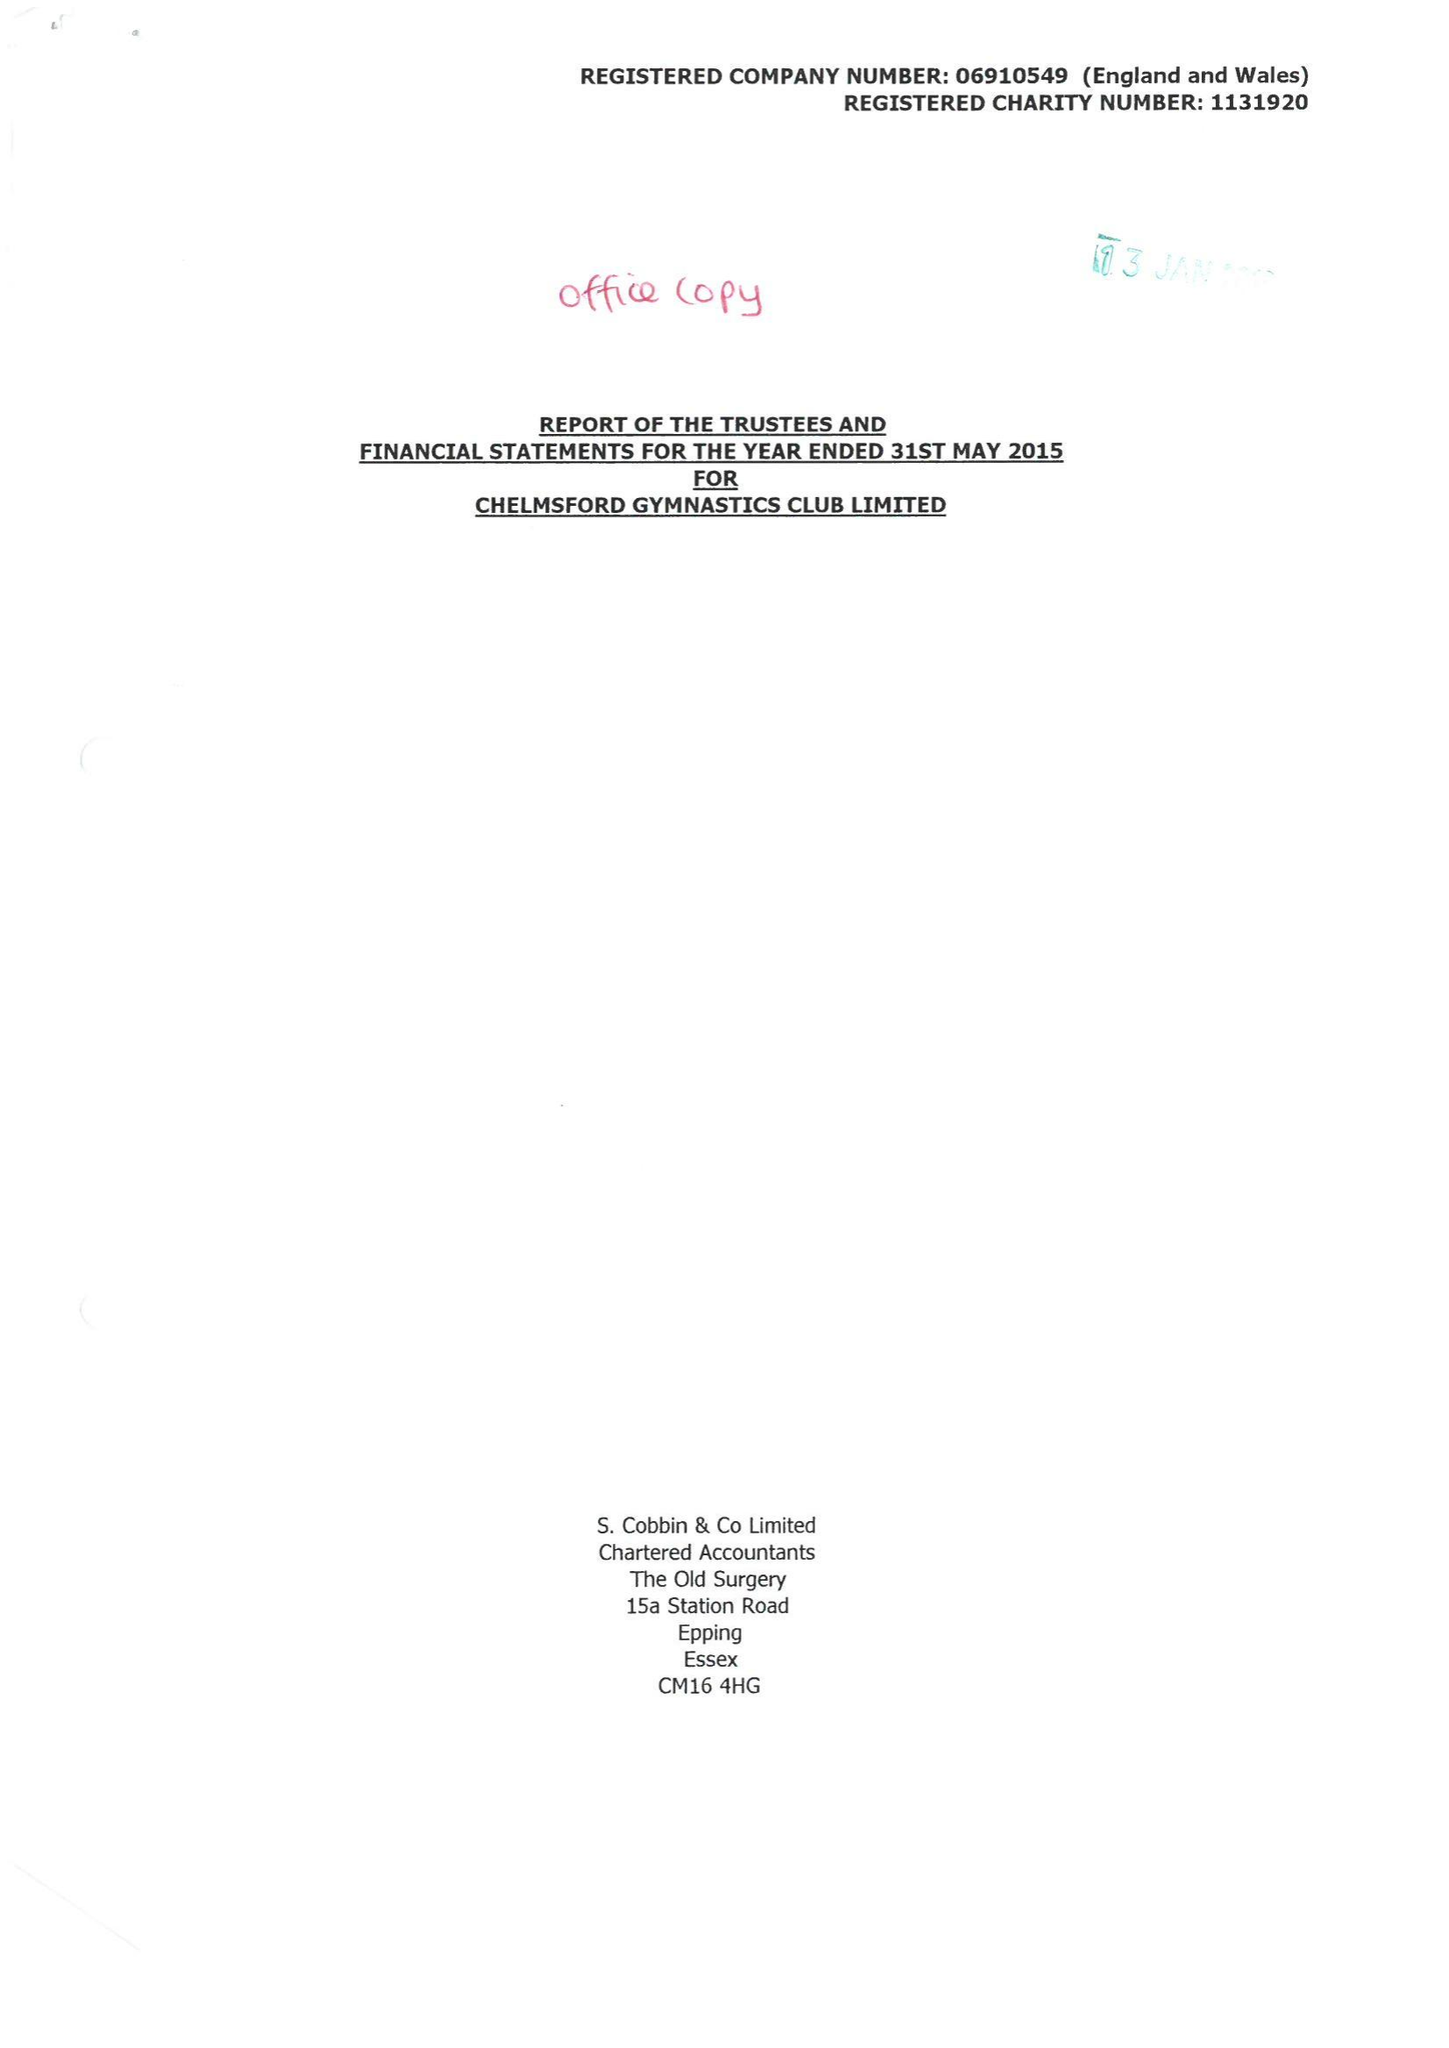What is the value for the report_date?
Answer the question using a single word or phrase. 2015-05-31 